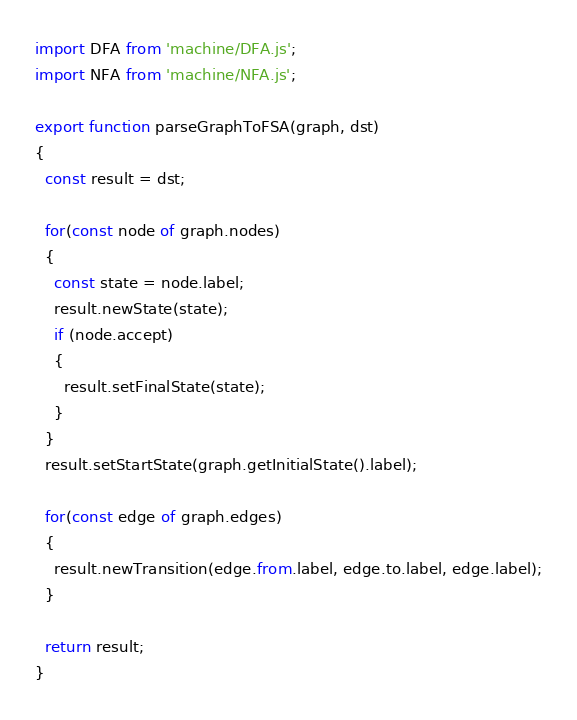Convert code to text. <code><loc_0><loc_0><loc_500><loc_500><_JavaScript_>import DFA from 'machine/DFA.js';
import NFA from 'machine/NFA.js';

export function parseGraphToFSA(graph, dst)
{
  const result = dst;

  for(const node of graph.nodes)
  {
    const state = node.label;
    result.newState(state);
    if (node.accept)
    {
      result.setFinalState(state);
    }
  }
  result.setStartState(graph.getInitialState().label);

  for(const edge of graph.edges)
  {
    result.newTransition(edge.from.label, edge.to.label, edge.label);
  }

  return result;
}
</code> 